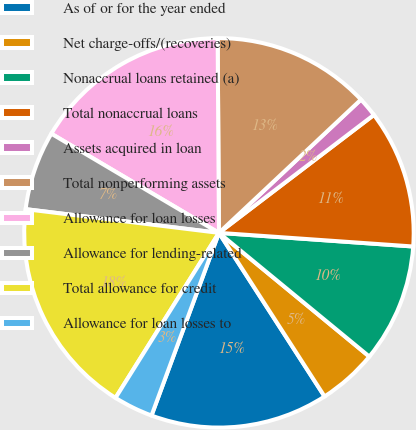Convert chart to OTSL. <chart><loc_0><loc_0><loc_500><loc_500><pie_chart><fcel>As of or for the year ended<fcel>Net charge-offs/(recoveries)<fcel>Nonaccrual loans retained (a)<fcel>Total nonaccrual loans<fcel>Assets acquired in loan<fcel>Total nonperforming assets<fcel>Allowance for loan losses<fcel>Allowance for lending-related<fcel>Total allowance for credit<fcel>Allowance for loan losses to<nl><fcel>14.75%<fcel>4.92%<fcel>9.84%<fcel>11.47%<fcel>1.64%<fcel>13.11%<fcel>16.39%<fcel>6.56%<fcel>18.03%<fcel>3.28%<nl></chart> 